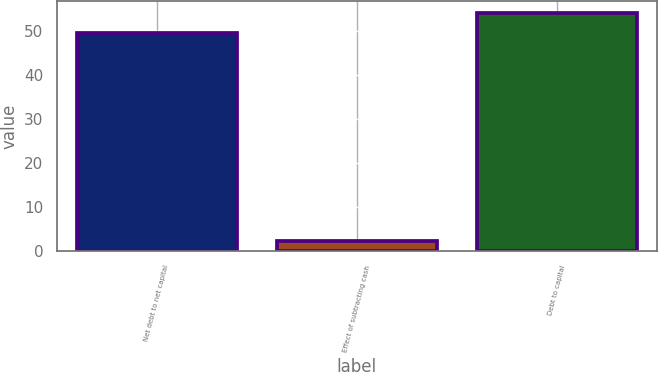<chart> <loc_0><loc_0><loc_500><loc_500><bar_chart><fcel>Net debt to net capital<fcel>Effect of subtracting cash<fcel>Debt to capital<nl><fcel>49.5<fcel>2.27<fcel>54.22<nl></chart> 